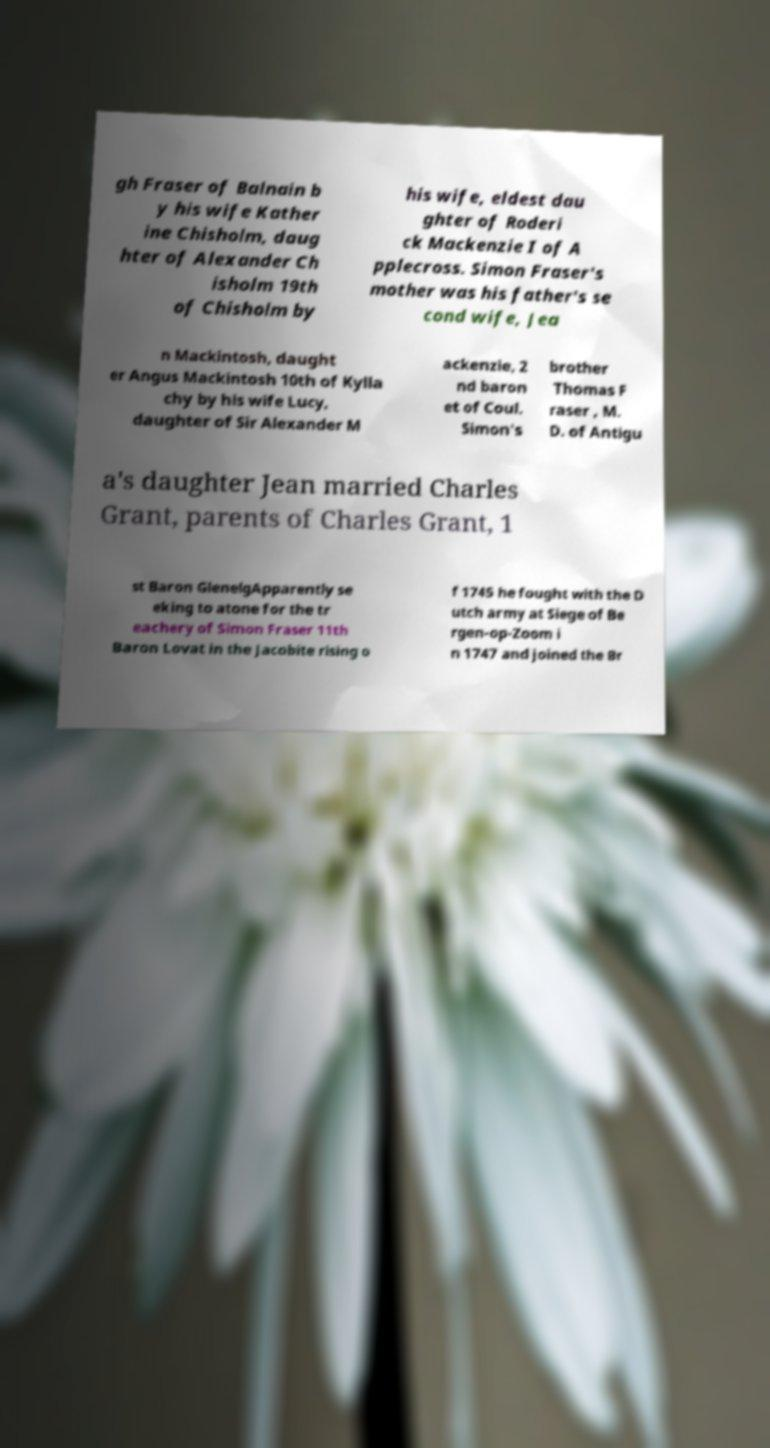Please identify and transcribe the text found in this image. gh Fraser of Balnain b y his wife Kather ine Chisholm, daug hter of Alexander Ch isholm 19th of Chisholm by his wife, eldest dau ghter of Roderi ck Mackenzie I of A pplecross. Simon Fraser's mother was his father's se cond wife, Jea n Mackintosh, daught er Angus Mackintosh 10th of Kylla chy by his wife Lucy, daughter of Sir Alexander M ackenzie, 2 nd baron et of Coul. Simon's brother Thomas F raser , M. D. of Antigu a's daughter Jean married Charles Grant, parents of Charles Grant, 1 st Baron GlenelgApparently se eking to atone for the tr eachery of Simon Fraser 11th Baron Lovat in the Jacobite rising o f 1745 he fought with the D utch army at Siege of Be rgen-op-Zoom i n 1747 and joined the Br 